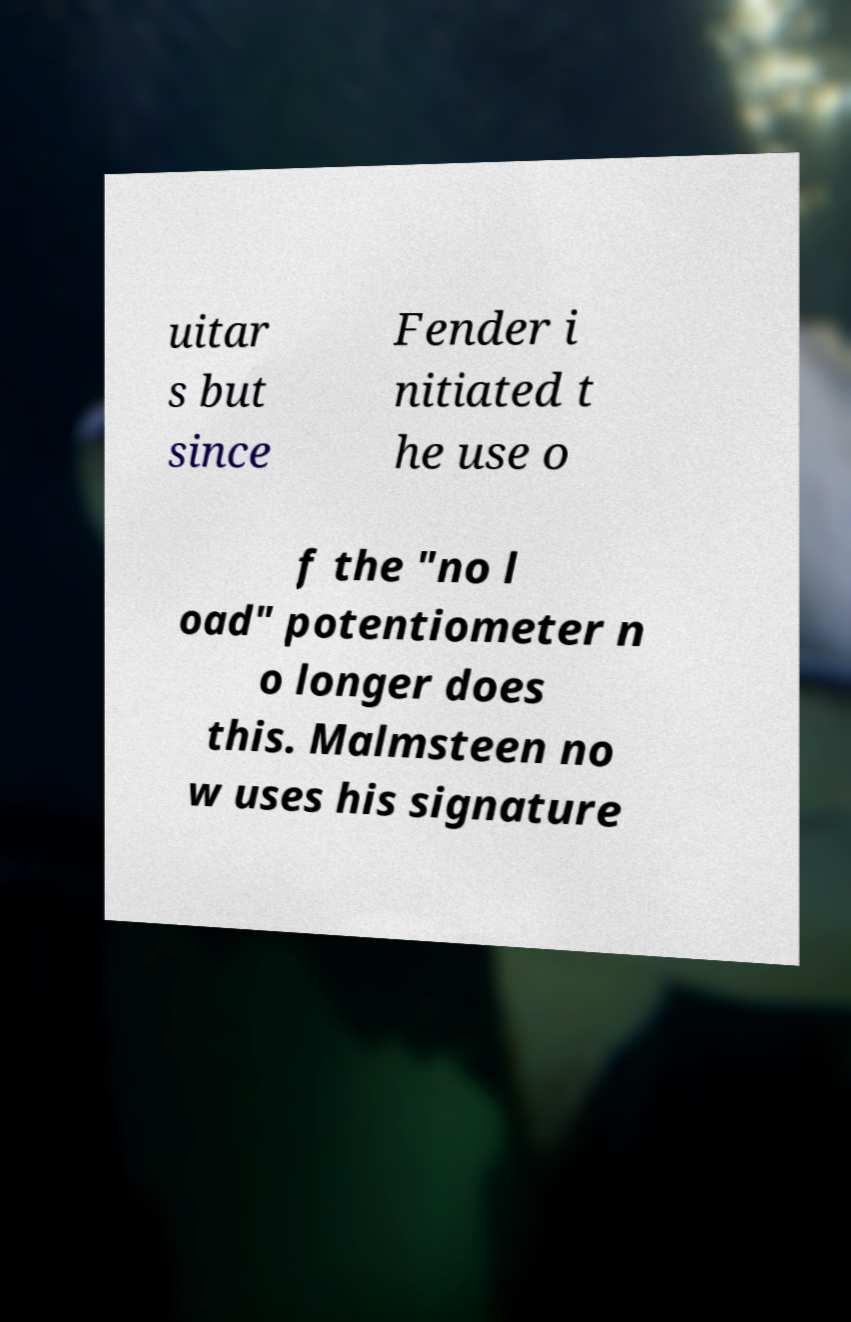What messages or text are displayed in this image? I need them in a readable, typed format. uitar s but since Fender i nitiated t he use o f the "no l oad" potentiometer n o longer does this. Malmsteen no w uses his signature 